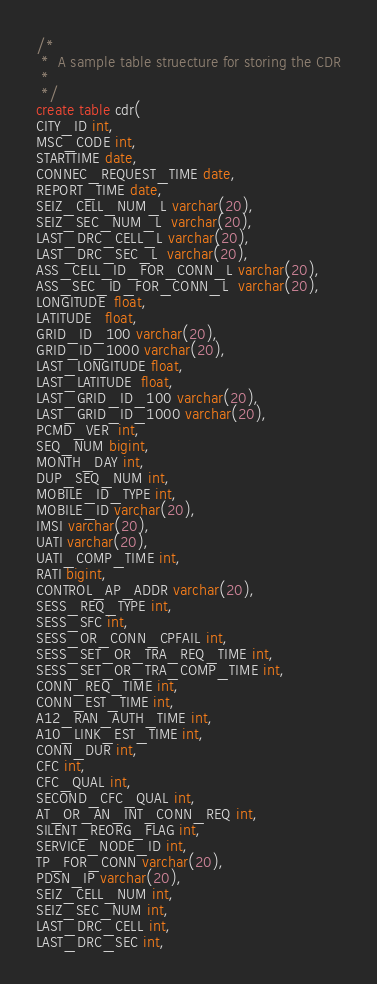<code> <loc_0><loc_0><loc_500><loc_500><_SQL_>/*
 *  A sample table struecture for storing the CDR
 *
 */
create table cdr(
CITY_ID int,
MSC_CODE int,
STARTTIME date,
CONNEC_REQUEST_TIME date,
REPORT_TIME date,
SEIZ_CELL_NUM_L varchar(20),
SEIZ_SEC_NUM_L  varchar(20),
LAST_DRC_CELL_L varchar(20),
LAST_DRC_SEC_L  varchar(20),
ASS_CELL_ID_FOR_CONN_L varchar(20),
ASS_SEC_ID_FOR_CONN_L  varchar(20),
LONGITUDE  float,
LATITUDE   float,
GRID_ID_100 varchar(20),
GRID_ID_1000 varchar(20),
LAST_LONGITUDE float,
LAST_LATITUDE  float,
LAST_GRID_ID_100 varchar(20),
LAST_GRID_ID_1000 varchar(20),
PCMD_VER  int,
SEQ_NUM bigint,
MONTH_DAY int,
DUP_SEQ_NUM int,
MOBILE_ID_TYPE int,
MOBILE_ID varchar(20),
IMSI varchar(20),
UATI varchar(20),
UATI_COMP_TIME int,
RATI bigint,
CONTROL_AP_ADDR varchar(20),
SESS_REQ_TYPE int,
SESS_SFC int,
SESS_OR_CONN_CPFAIL int,
SESS_SET_OR_TRA_REQ_TIME int,
SESS_SET_OR_TRA_COMP_TIME int,
CONN_REQ_TIME int,
CONN_EST_TIME int,
A12_RAN_AUTH_TIME int,
A10_LINK_EST_TIME int,
CONN_DUR int,
CFC int,
CFC_QUAL int,
SECOND_CFC_QUAL int,
AT_OR_AN_INT_CONN_REQ int,
SILENT_REORG_FLAG int,
SERVICE_NODE_ID int,
TP_FOR_CONN varchar(20), 
PDSN_IP varchar(20),
SEIZ_CELL_NUM int,
SEIZ_SEC_NUM int,
LAST_DRC_CELL int,
LAST_DRC_SEC int,</code> 